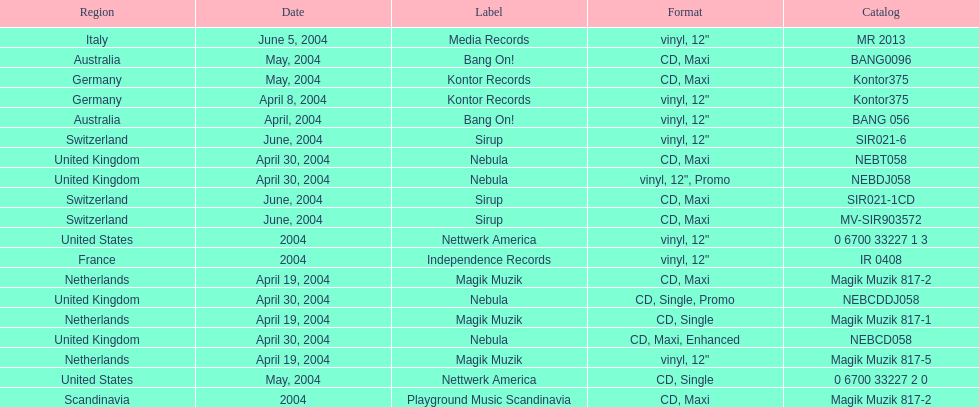What label was italy on? Media Records. 